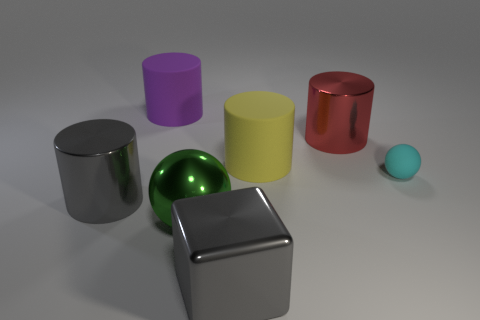Subtract all cubes. How many objects are left? 6 Add 1 gray shiny cylinders. How many objects exist? 8 Subtract all gray cylinders. How many cylinders are left? 3 Add 5 small blue matte spheres. How many small blue matte spheres exist? 5 Subtract all cyan balls. How many balls are left? 1 Subtract 0 brown cylinders. How many objects are left? 7 Subtract 1 spheres. How many spheres are left? 1 Subtract all cyan cylinders. Subtract all yellow spheres. How many cylinders are left? 4 Subtract all purple cylinders. How many brown cubes are left? 0 Subtract all big red cylinders. Subtract all big cyan metallic objects. How many objects are left? 6 